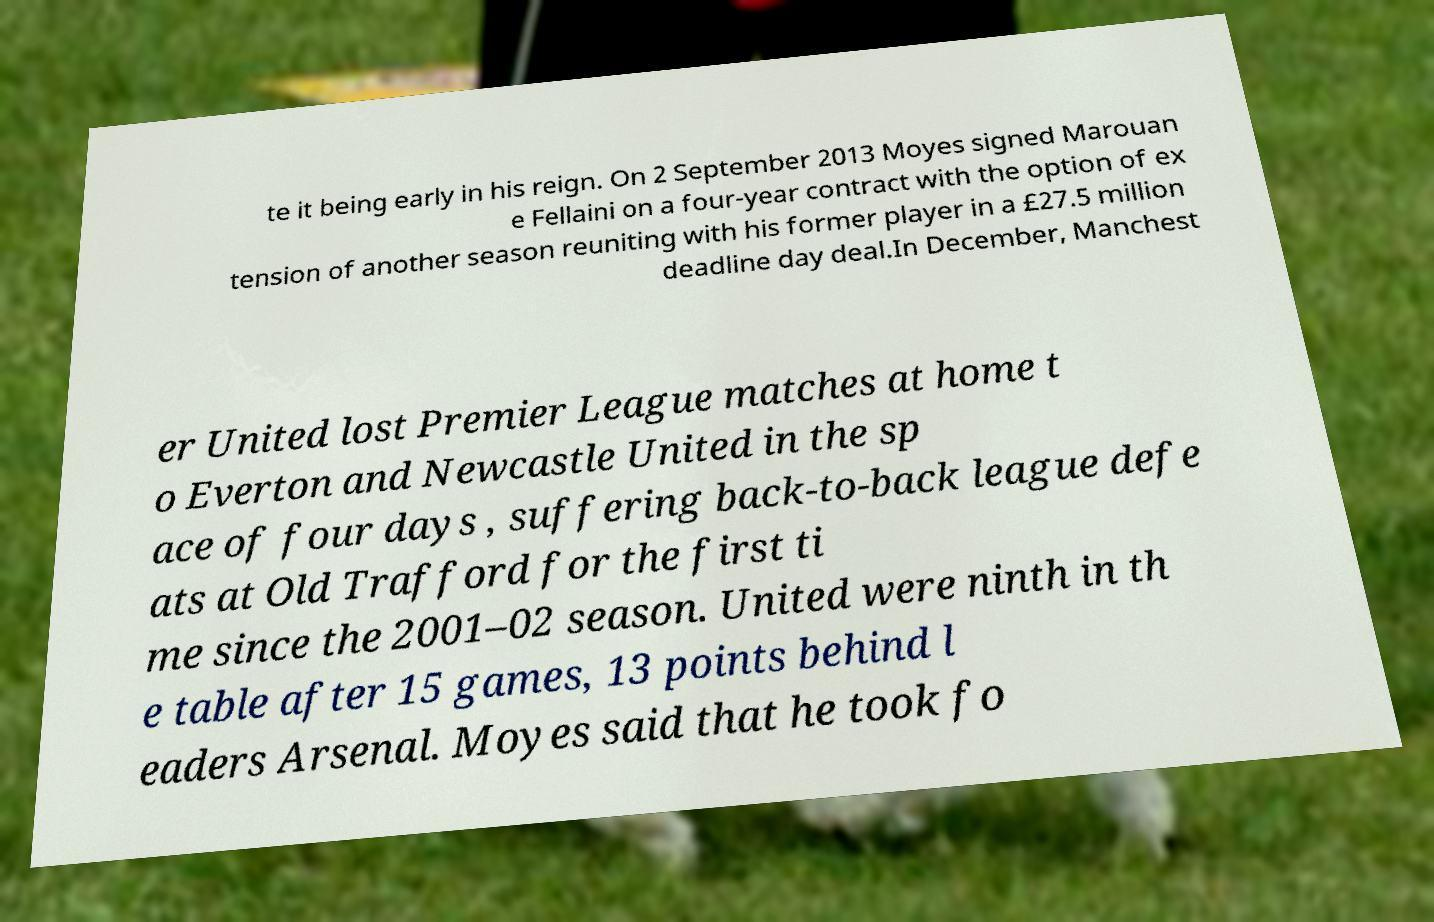There's text embedded in this image that I need extracted. Can you transcribe it verbatim? te it being early in his reign. On 2 September 2013 Moyes signed Marouan e Fellaini on a four-year contract with the option of ex tension of another season reuniting with his former player in a £27.5 million deadline day deal.In December, Manchest er United lost Premier League matches at home t o Everton and Newcastle United in the sp ace of four days , suffering back-to-back league defe ats at Old Trafford for the first ti me since the 2001–02 season. United were ninth in th e table after 15 games, 13 points behind l eaders Arsenal. Moyes said that he took fo 